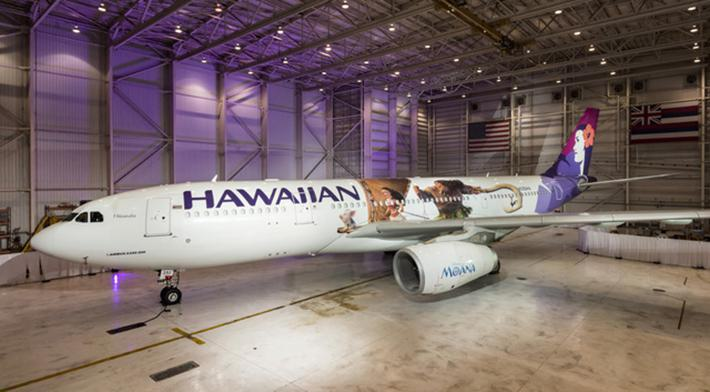How many unicorns are there in the image? 0 